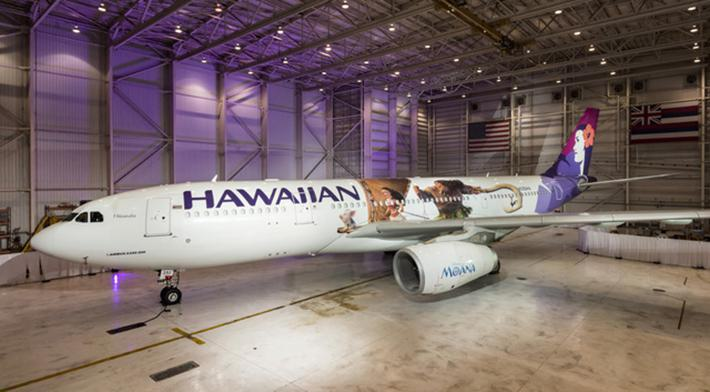How many unicorns are there in the image? 0 